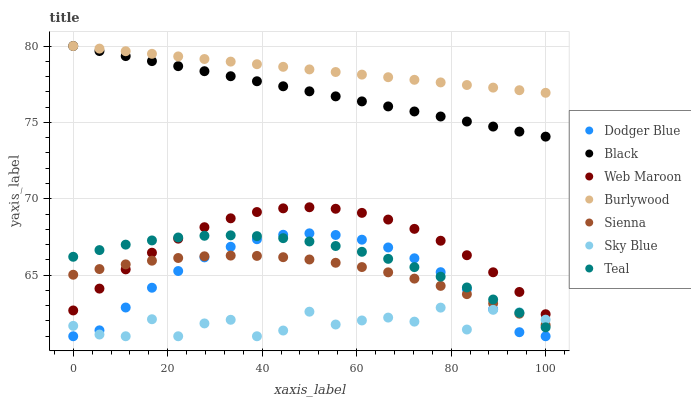Does Sky Blue have the minimum area under the curve?
Answer yes or no. Yes. Does Burlywood have the maximum area under the curve?
Answer yes or no. Yes. Does Web Maroon have the minimum area under the curve?
Answer yes or no. No. Does Web Maroon have the maximum area under the curve?
Answer yes or no. No. Is Burlywood the smoothest?
Answer yes or no. Yes. Is Sky Blue the roughest?
Answer yes or no. Yes. Is Web Maroon the smoothest?
Answer yes or no. No. Is Web Maroon the roughest?
Answer yes or no. No. Does Dodger Blue have the lowest value?
Answer yes or no. Yes. Does Web Maroon have the lowest value?
Answer yes or no. No. Does Black have the highest value?
Answer yes or no. Yes. Does Web Maroon have the highest value?
Answer yes or no. No. Is Web Maroon less than Black?
Answer yes or no. Yes. Is Burlywood greater than Web Maroon?
Answer yes or no. Yes. Does Dodger Blue intersect Teal?
Answer yes or no. Yes. Is Dodger Blue less than Teal?
Answer yes or no. No. Is Dodger Blue greater than Teal?
Answer yes or no. No. Does Web Maroon intersect Black?
Answer yes or no. No. 